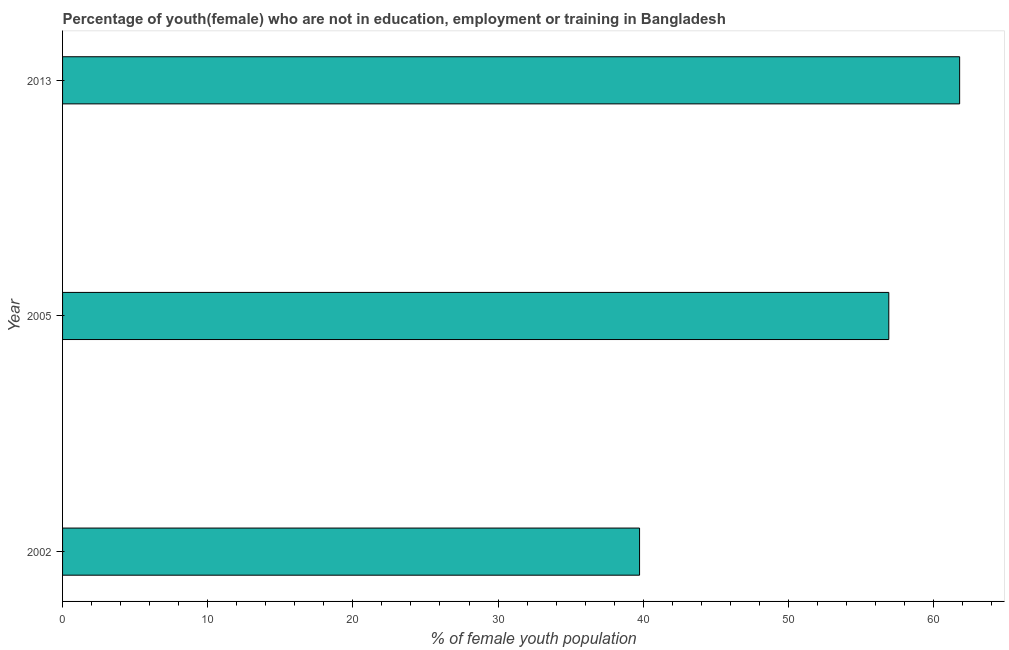What is the title of the graph?
Give a very brief answer. Percentage of youth(female) who are not in education, employment or training in Bangladesh. What is the label or title of the X-axis?
Offer a very short reply. % of female youth population. What is the label or title of the Y-axis?
Offer a terse response. Year. What is the unemployed female youth population in 2005?
Your response must be concise. 56.92. Across all years, what is the maximum unemployed female youth population?
Your answer should be very brief. 61.8. Across all years, what is the minimum unemployed female youth population?
Offer a terse response. 39.75. In which year was the unemployed female youth population maximum?
Give a very brief answer. 2013. In which year was the unemployed female youth population minimum?
Your answer should be very brief. 2002. What is the sum of the unemployed female youth population?
Offer a very short reply. 158.47. What is the difference between the unemployed female youth population in 2002 and 2005?
Make the answer very short. -17.17. What is the average unemployed female youth population per year?
Provide a succinct answer. 52.82. What is the median unemployed female youth population?
Give a very brief answer. 56.92. What is the ratio of the unemployed female youth population in 2005 to that in 2013?
Make the answer very short. 0.92. Is the unemployed female youth population in 2002 less than that in 2005?
Ensure brevity in your answer.  Yes. What is the difference between the highest and the second highest unemployed female youth population?
Make the answer very short. 4.88. What is the difference between the highest and the lowest unemployed female youth population?
Give a very brief answer. 22.05. In how many years, is the unemployed female youth population greater than the average unemployed female youth population taken over all years?
Your answer should be compact. 2. Are all the bars in the graph horizontal?
Keep it short and to the point. Yes. How many years are there in the graph?
Ensure brevity in your answer.  3. What is the difference between two consecutive major ticks on the X-axis?
Make the answer very short. 10. Are the values on the major ticks of X-axis written in scientific E-notation?
Provide a succinct answer. No. What is the % of female youth population of 2002?
Keep it short and to the point. 39.75. What is the % of female youth population of 2005?
Make the answer very short. 56.92. What is the % of female youth population in 2013?
Make the answer very short. 61.8. What is the difference between the % of female youth population in 2002 and 2005?
Offer a very short reply. -17.17. What is the difference between the % of female youth population in 2002 and 2013?
Make the answer very short. -22.05. What is the difference between the % of female youth population in 2005 and 2013?
Offer a very short reply. -4.88. What is the ratio of the % of female youth population in 2002 to that in 2005?
Provide a succinct answer. 0.7. What is the ratio of the % of female youth population in 2002 to that in 2013?
Provide a short and direct response. 0.64. What is the ratio of the % of female youth population in 2005 to that in 2013?
Your answer should be compact. 0.92. 